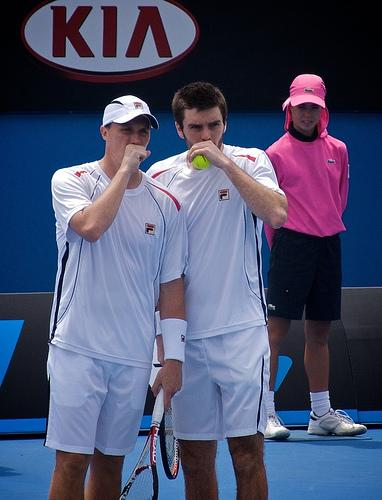How many people are wearing wristbands in the image? And what color are they? There is one person wearing a white wristband. Can you provide information about the tennis rackets seen in the image? There are red, white, and black tennis rackets held by at least two men in the image. In the image, describe the person in the back, including their clothing. The person in the back is wearing a pink shirt, black shorts, a bright pink hat with side flaps, white shoes and has an alligator logo on their shirt. Give a detailed description of the hat worn by the man in the image. The man in the image is wearing a white and black ball cap. Tell me something interesting about the tennis player's outfit. The male tennis player is wearing white shorts with a pocket showing through, and a white shirt with red and black trim. Identify the type of sport in the image, and mention an object that is being held. The sport is tennis, and a tennis racket is being held by a man. What do the two men have in front of their mouths? The two men have their hands in front of their mouths. Describe the shoes of the person in the image who is wearing socks. The person with socks is wearing white tennis shoes. What is the color of the floor of the court in the image? The floor of the court is blue. What type of logo can be found in the background of the image? A car company logo, specifically Kia, can be found in the background. Select the item with these coordinates: X:171 Y:81 Width:82 Height:82 Guy holding tennis ball What is present at location X:320 Y:155? Alligator logo on pink shirt Identify the sentiment portrayed in the image. Positive and competitive List down the object captions related to people's attire. person in back wearing pink, man has white shorts on, white shirt with red and black trim, sweat band on mans wrist, woman dressed to avoid sun exposure, guy wearing white cap, black stripe on side of white shirt, red stripes on white shoulders on shirt, person wearing pink shirt, white wristband on arm, male tennis player wearing white shorts, male tennis player wearing white shirt, young woman wearing pink and black sweater, woman wearing black shorts, woman wearing white shoes Identify which object is related to the Referential Expression Grounding Task. the logo What is the quality status of the image: is it low or high quality? High quality Describe the clothes worn by the male tennis players. White shorts, white shirt with red and black trim, sweatband on wrist, white cap Extract the text found in the image. KIA, red and white sign State the color of the hat worn by the person in back. Pink Which item is commonly used in playing tennis? tennis racket What object is found at location X:297 Y:372? The person has socks and shoes on What kind of caps are worn by people in the image?  White and pink caps Identify the object found at coordinates X:140 Y:294. A white wristband on arm Segment the image by listing the objects and their corresponding locations. KIA logo: X:22 Y:0 Width:191 Height:191, blue floor: X:279 Y:446 Width:58 Height:58, tennis rackets: X:123 Y:361 Width:80 Height:80, pink clothing: X:264 Y:59 Width:106 Height:106, white shorts: X:53 Y:338 Width:89 Height:89 Find the image region with the car company logo. X:15 Y:1 Width:197 Height:197 Describe how the tennis players are interacting in the image. Both are focused, one holding racket and ball, preparing for a game Describe the woman's outfit in the picture. Pink and black sweater, black shorts, white shoes, pink cap What is the dominant feeling portrayed in the image? Competitive spirit 